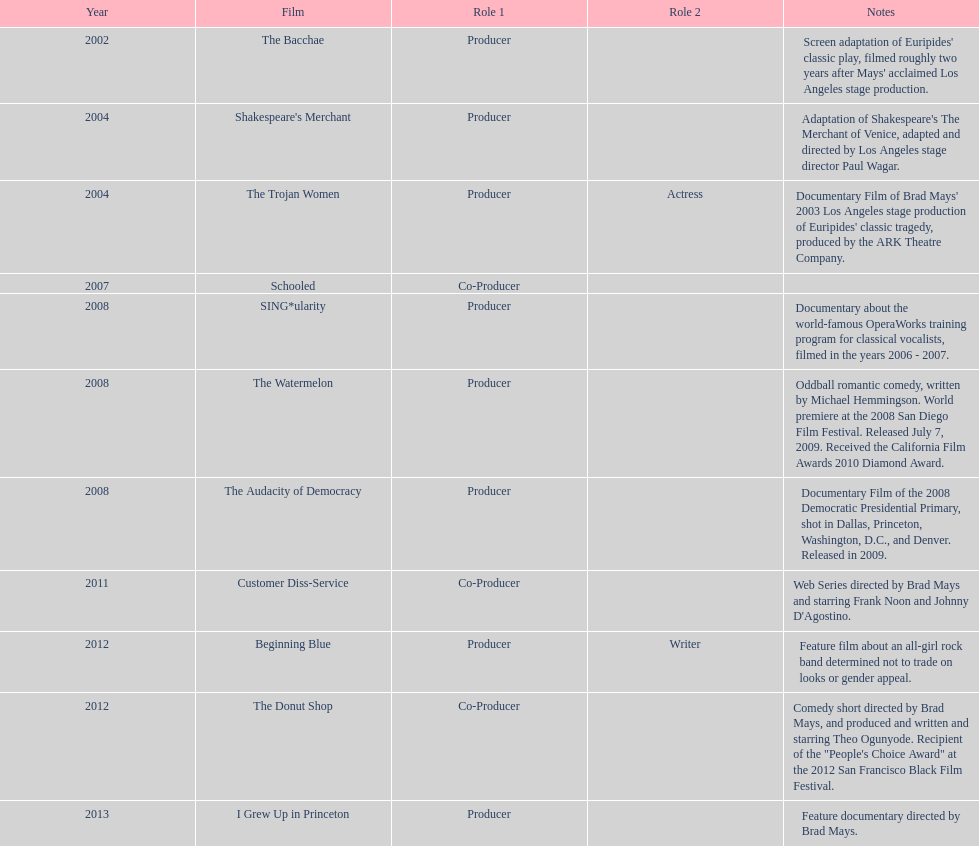How many films did ms. starfelt produce after 2010? 4. 